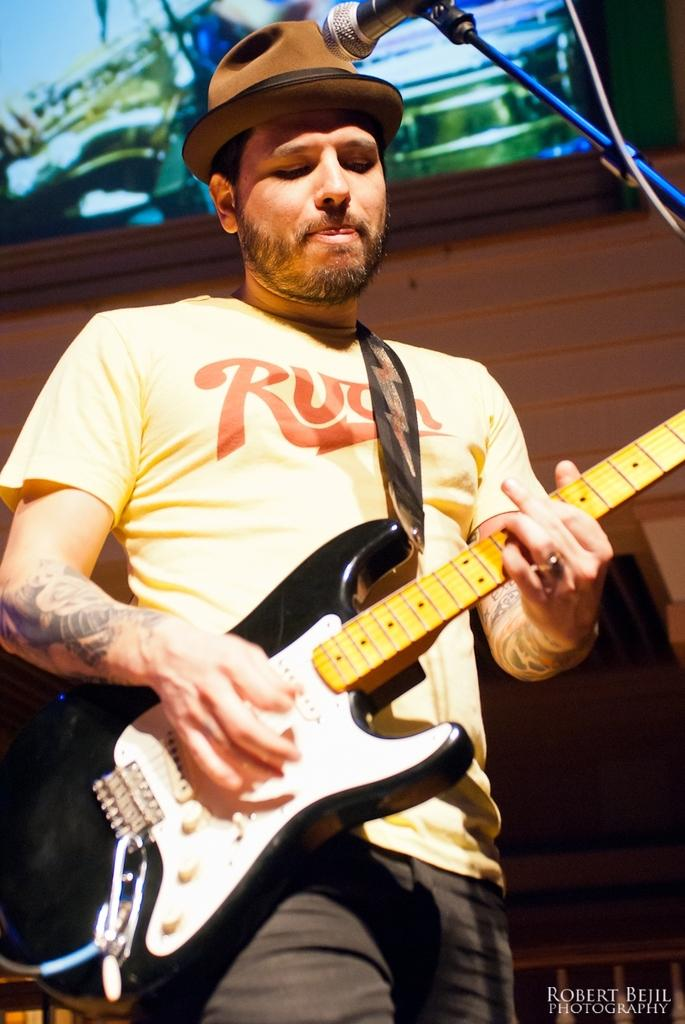What color is the t-shirt the man is wearing in the image? The man is wearing a yellow t-shirt. What type of headwear is the man wearing? The man is wearing a cap. What object is the man holding in the image? The man is holding a guitar. What is the man doing with the guitar? The man is playing the guitar. What can be seen in front of the man? There is a mic stand in front of the man. What is present in the background of the image? There is a photo frame in the background. What shape is the language the man is speaking in the image? The image does not provide any information about the language the man is speaking, nor does it depict any shapes related to language. 